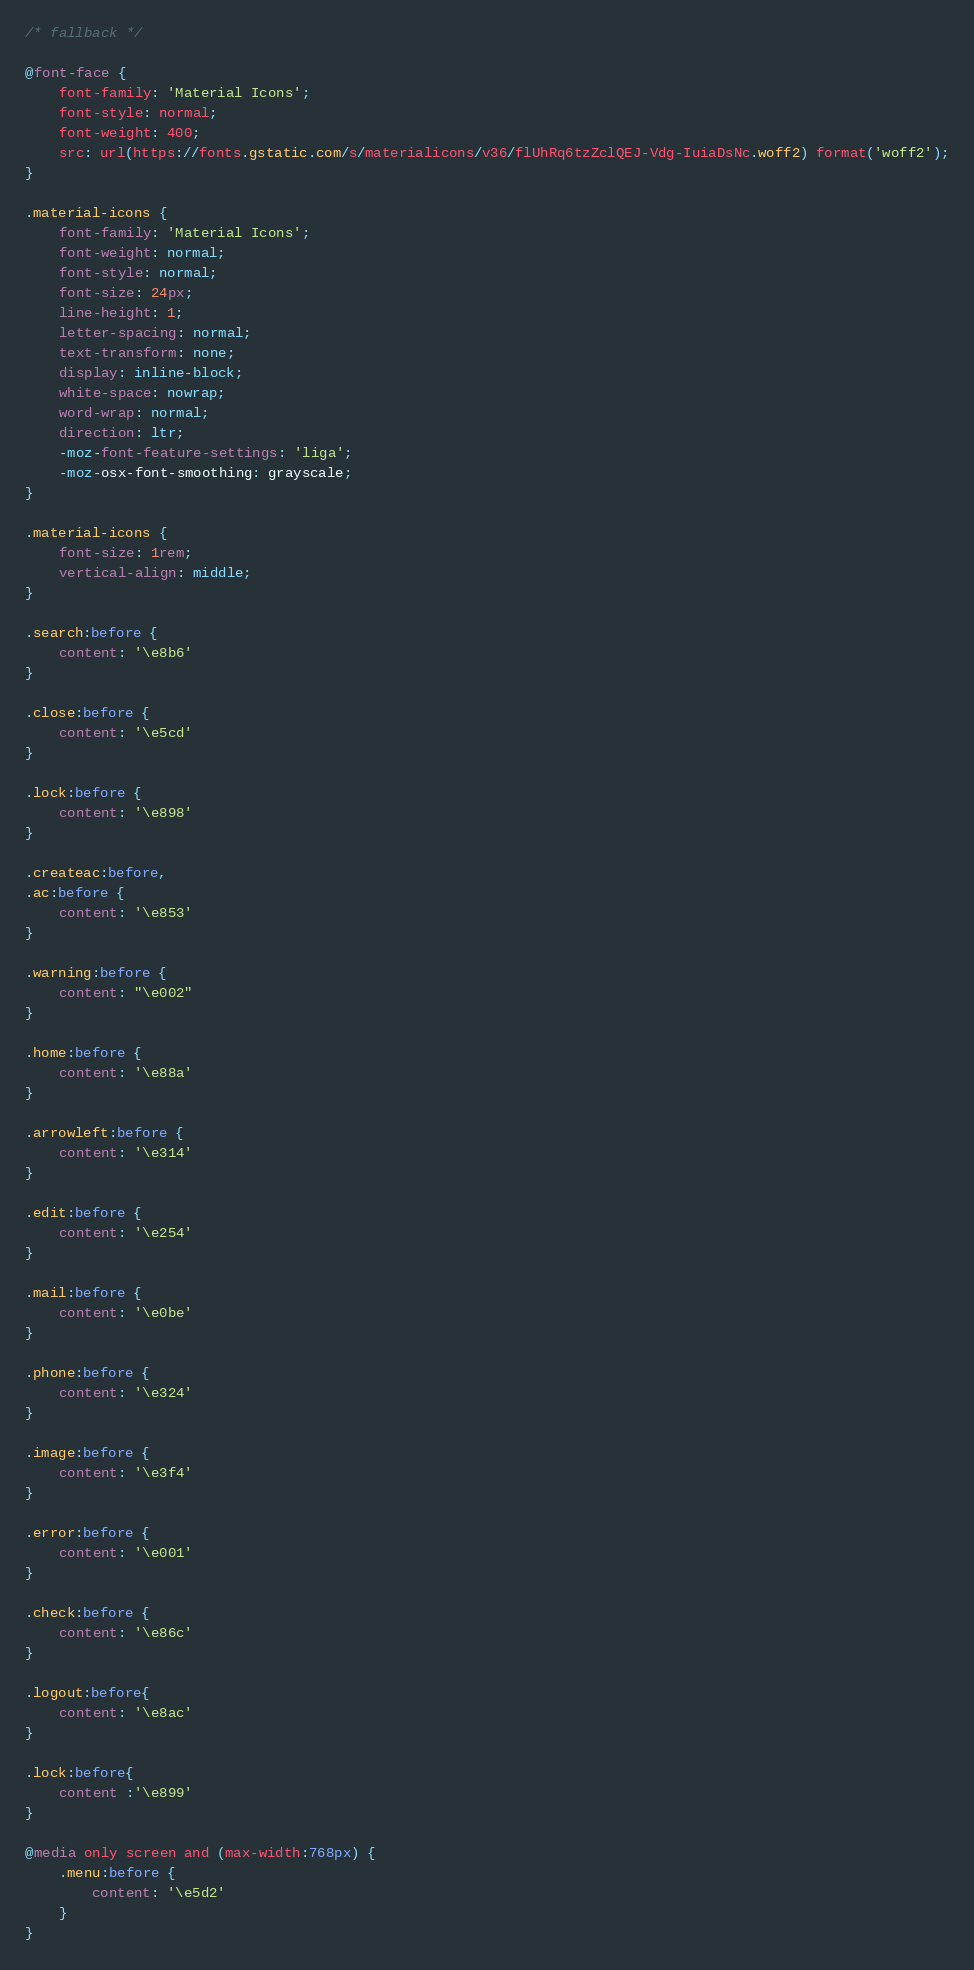Convert code to text. <code><loc_0><loc_0><loc_500><loc_500><_CSS_>/* fallback */

@font-face {
    font-family: 'Material Icons';
    font-style: normal;
    font-weight: 400;
    src: url(https://fonts.gstatic.com/s/materialicons/v36/flUhRq6tzZclQEJ-Vdg-IuiaDsNc.woff2) format('woff2');
}

.material-icons {
    font-family: 'Material Icons';
    font-weight: normal;
    font-style: normal;
    font-size: 24px;
    line-height: 1;
    letter-spacing: normal;
    text-transform: none;
    display: inline-block;
    white-space: nowrap;
    word-wrap: normal;
    direction: ltr;
    -moz-font-feature-settings: 'liga';
    -moz-osx-font-smoothing: grayscale;
}

.material-icons {
    font-size: 1rem;
    vertical-align: middle;
}

.search:before {
    content: '\e8b6'
}

.close:before {
    content: '\e5cd'
}

.lock:before {
    content: '\e898'
}

.createac:before,
.ac:before {
    content: '\e853'
}

.warning:before {
    content: "\e002"
}

.home:before {
    content: '\e88a'
}

.arrowleft:before {
    content: '\e314'
}

.edit:before {
    content: '\e254'
}

.mail:before {
    content: '\e0be'
}

.phone:before {
    content: '\e324'
}

.image:before {
    content: '\e3f4'
}

.error:before {
    content: '\e001'
}

.check:before {
    content: '\e86c'
}

.logout:before{
    content: '\e8ac'   
}

.lock:before{
    content :'\e899'
}

@media only screen and (max-width:768px) {
    .menu:before {
        content: '\e5d2'
    }
}</code> 